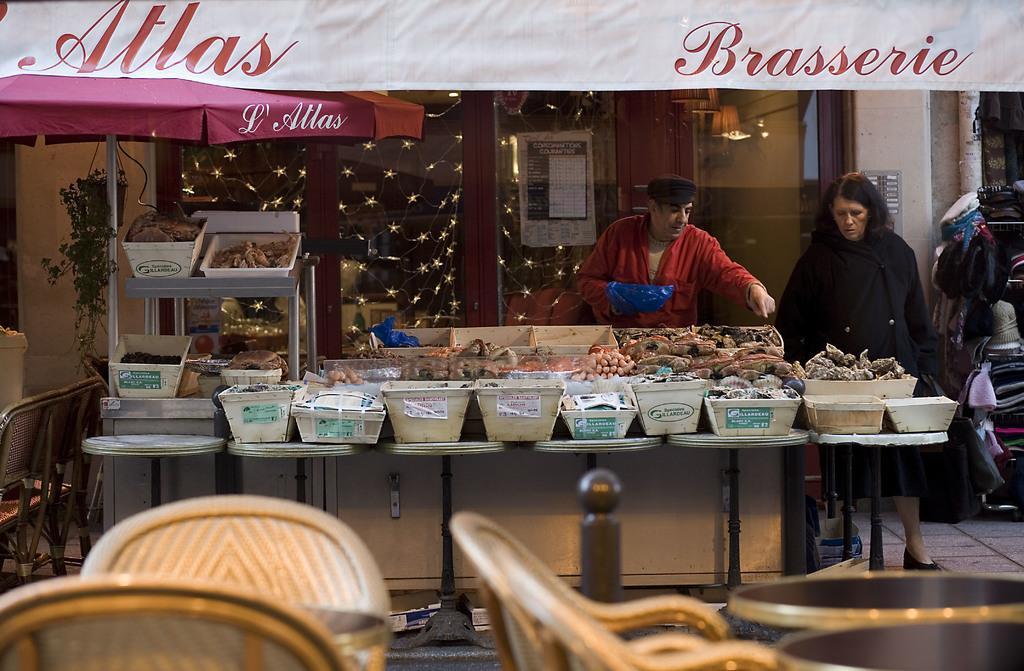How would you summarize this image in a sentence or two? In this picture we can see chairs at the bottom, thee are some tables in the middle, we can see some trays on the table, on the left side there is an umbrella, in the background there are glasses, lights, a banner and two persons, there are some things present on these trays. 